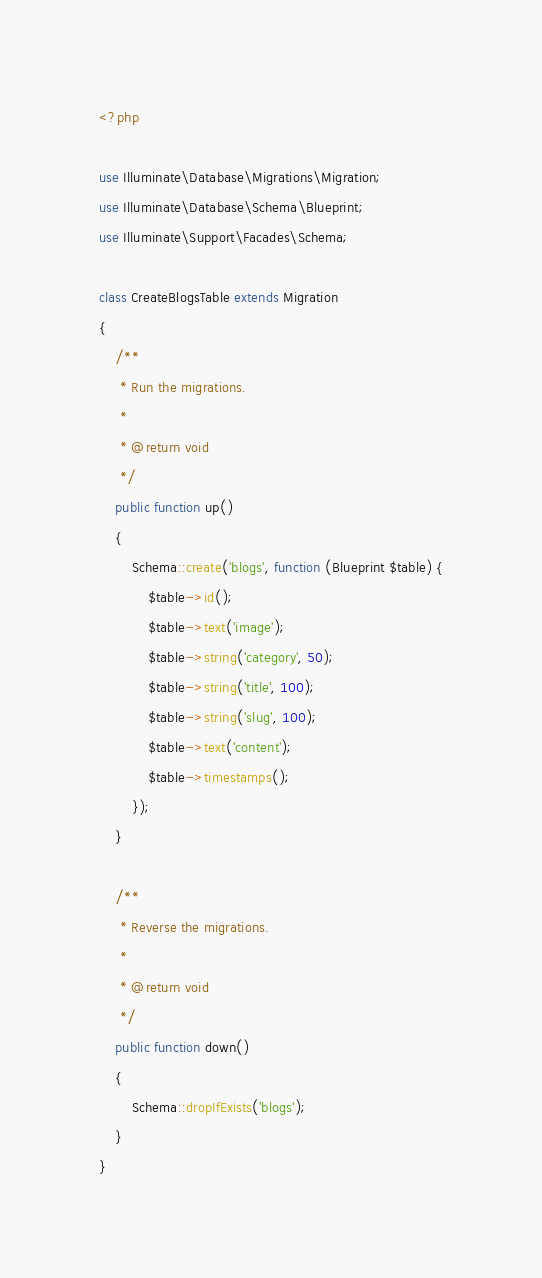Convert code to text. <code><loc_0><loc_0><loc_500><loc_500><_PHP_><?php

use Illuminate\Database\Migrations\Migration;
use Illuminate\Database\Schema\Blueprint;
use Illuminate\Support\Facades\Schema;

class CreateBlogsTable extends Migration
{
    /**
     * Run the migrations.
     *
     * @return void
     */
    public function up()
    {
        Schema::create('blogs', function (Blueprint $table) {
            $table->id();
            $table->text('image');
            $table->string('category', 50);
            $table->string('title', 100);
            $table->string('slug', 100);
            $table->text('content');
            $table->timestamps();
        });
    }

    /**
     * Reverse the migrations.
     *
     * @return void
     */
    public function down()
    {
        Schema::dropIfExists('blogs');
    }
}
</code> 